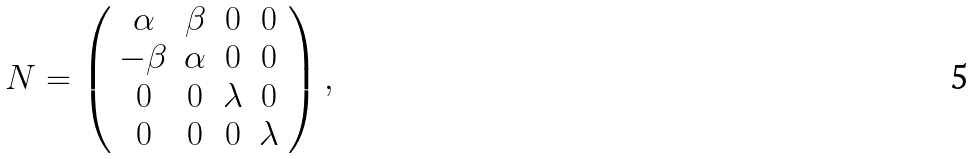Convert formula to latex. <formula><loc_0><loc_0><loc_500><loc_500>N = \left ( \begin{array} { c c c c } \alpha & \beta & 0 & 0 \\ - \beta & \alpha & 0 & 0 \\ 0 & 0 & \lambda & 0 \\ 0 & 0 & 0 & \lambda \end{array} \right ) ,</formula> 